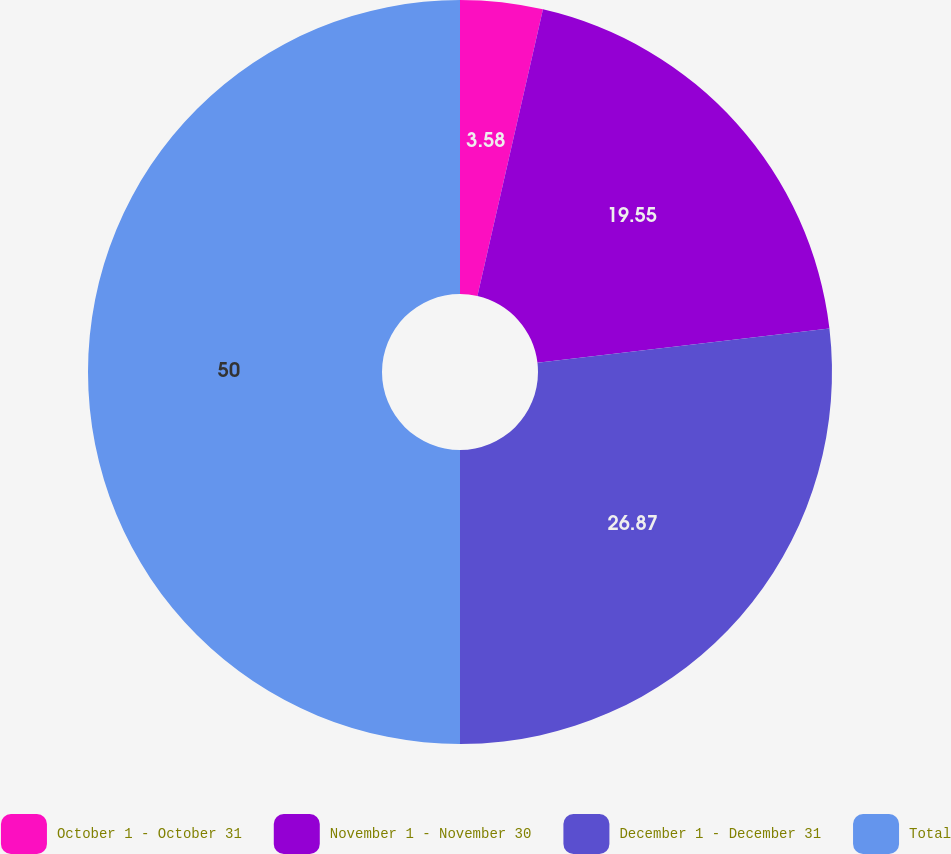Convert chart. <chart><loc_0><loc_0><loc_500><loc_500><pie_chart><fcel>October 1 - October 31<fcel>November 1 - November 30<fcel>December 1 - December 31<fcel>Total<nl><fcel>3.58%<fcel>19.55%<fcel>26.87%<fcel>50.0%<nl></chart> 